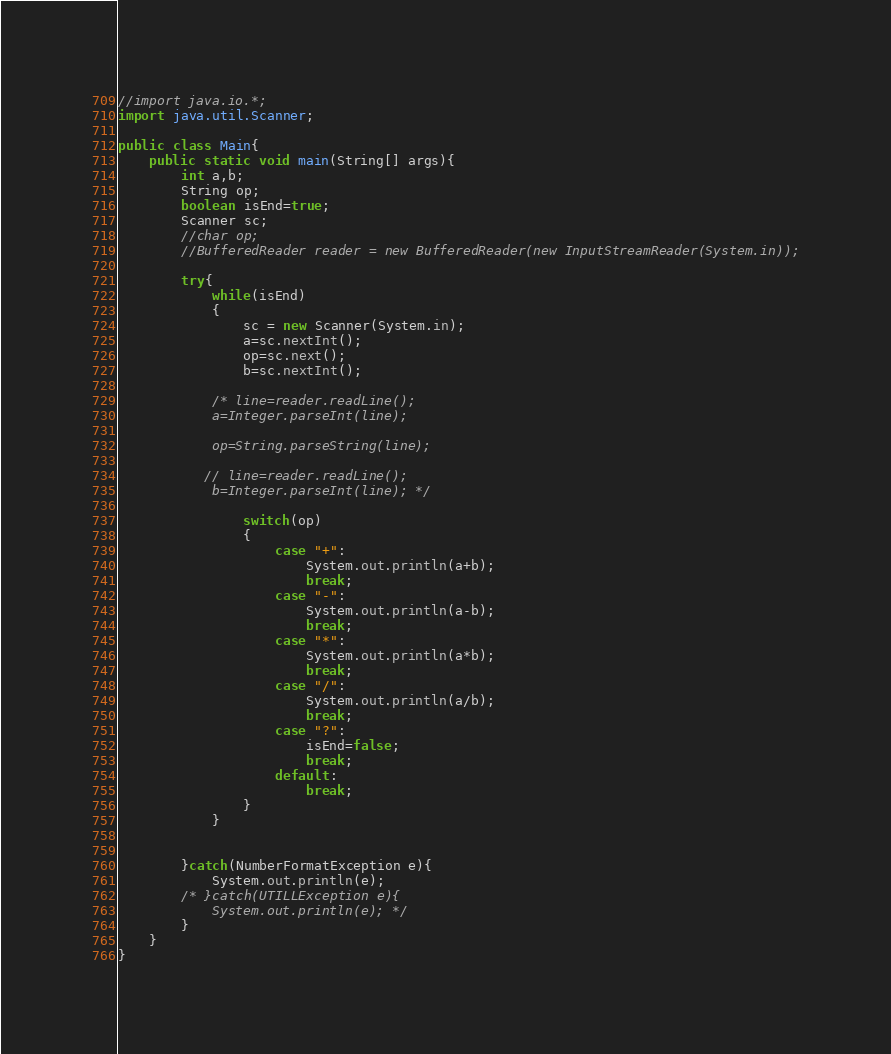Convert code to text. <code><loc_0><loc_0><loc_500><loc_500><_Java_>//import java.io.*;
import java.util.Scanner;

public class Main{
    public static void main(String[] args){
        int a,b;
        String op;
        boolean isEnd=true;
        Scanner sc;
        //char op;
        //BufferedReader reader = new BufferedReader(new InputStreamReader(System.in));

        try{
            while(isEnd)
            {
                sc = new Scanner(System.in);
                a=sc.nextInt();
                op=sc.next();
                b=sc.nextInt();

            /* line=reader.readLine();
            a=Integer.parseInt(line);

            op=String.parseString(line);

           // line=reader.readLine();
            b=Integer.parseInt(line); */

                switch(op)
                {
                    case "+":
                        System.out.println(a+b);
                        break;
                    case "-":
                        System.out.println(a-b);
                        break;
                    case "*":
                        System.out.println(a*b);
                        break;
                    case "/":
                        System.out.println(a/b);
                        break;
                    case "?":
                        isEnd=false;
                        break;
                    default:
                        break;
                }
            }
            

        }catch(NumberFormatException e){
            System.out.println(e);
        /* }catch(UTILLException e){
            System.out.println(e); */
        }
    }
}
</code> 